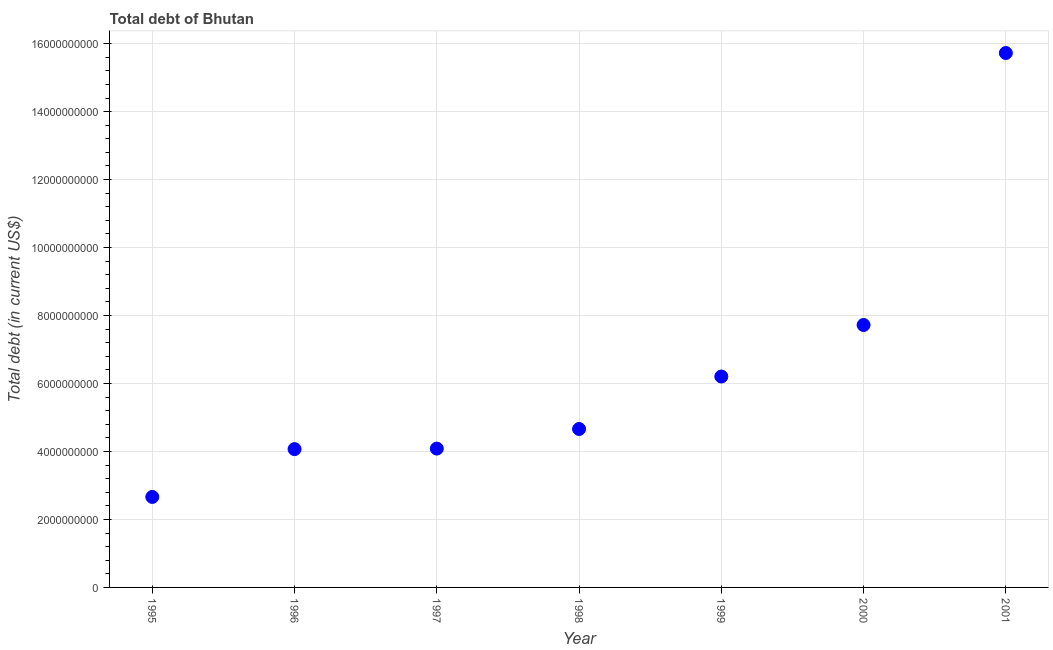What is the total debt in 2000?
Provide a short and direct response. 7.72e+09. Across all years, what is the maximum total debt?
Provide a succinct answer. 1.57e+1. Across all years, what is the minimum total debt?
Provide a short and direct response. 2.66e+09. In which year was the total debt maximum?
Offer a very short reply. 2001. In which year was the total debt minimum?
Give a very brief answer. 1995. What is the sum of the total debt?
Provide a short and direct response. 4.51e+1. What is the difference between the total debt in 1995 and 1998?
Your answer should be very brief. -2.00e+09. What is the average total debt per year?
Keep it short and to the point. 6.45e+09. What is the median total debt?
Make the answer very short. 4.66e+09. What is the ratio of the total debt in 1999 to that in 2000?
Your response must be concise. 0.8. Is the difference between the total debt in 1999 and 2001 greater than the difference between any two years?
Provide a short and direct response. No. What is the difference between the highest and the second highest total debt?
Keep it short and to the point. 8.00e+09. What is the difference between the highest and the lowest total debt?
Make the answer very short. 1.31e+1. In how many years, is the total debt greater than the average total debt taken over all years?
Your answer should be compact. 2. Does the total debt monotonically increase over the years?
Give a very brief answer. Yes. How many dotlines are there?
Provide a short and direct response. 1. How many years are there in the graph?
Your answer should be compact. 7. What is the difference between two consecutive major ticks on the Y-axis?
Give a very brief answer. 2.00e+09. Does the graph contain grids?
Offer a very short reply. Yes. What is the title of the graph?
Make the answer very short. Total debt of Bhutan. What is the label or title of the Y-axis?
Keep it short and to the point. Total debt (in current US$). What is the Total debt (in current US$) in 1995?
Offer a very short reply. 2.66e+09. What is the Total debt (in current US$) in 1996?
Make the answer very short. 4.07e+09. What is the Total debt (in current US$) in 1997?
Your answer should be very brief. 4.08e+09. What is the Total debt (in current US$) in 1998?
Your answer should be compact. 4.66e+09. What is the Total debt (in current US$) in 1999?
Provide a short and direct response. 6.21e+09. What is the Total debt (in current US$) in 2000?
Give a very brief answer. 7.72e+09. What is the Total debt (in current US$) in 2001?
Offer a very short reply. 1.57e+1. What is the difference between the Total debt (in current US$) in 1995 and 1996?
Your answer should be compact. -1.41e+09. What is the difference between the Total debt (in current US$) in 1995 and 1997?
Your answer should be very brief. -1.42e+09. What is the difference between the Total debt (in current US$) in 1995 and 1998?
Offer a terse response. -2.00e+09. What is the difference between the Total debt (in current US$) in 1995 and 1999?
Offer a very short reply. -3.54e+09. What is the difference between the Total debt (in current US$) in 1995 and 2000?
Give a very brief answer. -5.06e+09. What is the difference between the Total debt (in current US$) in 1995 and 2001?
Ensure brevity in your answer.  -1.31e+1. What is the difference between the Total debt (in current US$) in 1996 and 1997?
Provide a short and direct response. -1.54e+07. What is the difference between the Total debt (in current US$) in 1996 and 1998?
Keep it short and to the point. -5.92e+08. What is the difference between the Total debt (in current US$) in 1996 and 1999?
Give a very brief answer. -2.14e+09. What is the difference between the Total debt (in current US$) in 1996 and 2000?
Offer a very short reply. -3.65e+09. What is the difference between the Total debt (in current US$) in 1996 and 2001?
Provide a short and direct response. -1.17e+1. What is the difference between the Total debt (in current US$) in 1997 and 1998?
Keep it short and to the point. -5.76e+08. What is the difference between the Total debt (in current US$) in 1997 and 1999?
Offer a very short reply. -2.12e+09. What is the difference between the Total debt (in current US$) in 1997 and 2000?
Give a very brief answer. -3.64e+09. What is the difference between the Total debt (in current US$) in 1997 and 2001?
Your response must be concise. -1.16e+1. What is the difference between the Total debt (in current US$) in 1998 and 1999?
Your answer should be compact. -1.54e+09. What is the difference between the Total debt (in current US$) in 1998 and 2000?
Offer a terse response. -3.06e+09. What is the difference between the Total debt (in current US$) in 1998 and 2001?
Make the answer very short. -1.11e+1. What is the difference between the Total debt (in current US$) in 1999 and 2000?
Your answer should be compact. -1.52e+09. What is the difference between the Total debt (in current US$) in 1999 and 2001?
Your response must be concise. -9.52e+09. What is the difference between the Total debt (in current US$) in 2000 and 2001?
Your answer should be compact. -8.00e+09. What is the ratio of the Total debt (in current US$) in 1995 to that in 1996?
Offer a very short reply. 0.65. What is the ratio of the Total debt (in current US$) in 1995 to that in 1997?
Make the answer very short. 0.65. What is the ratio of the Total debt (in current US$) in 1995 to that in 1998?
Give a very brief answer. 0.57. What is the ratio of the Total debt (in current US$) in 1995 to that in 1999?
Your answer should be compact. 0.43. What is the ratio of the Total debt (in current US$) in 1995 to that in 2000?
Give a very brief answer. 0.34. What is the ratio of the Total debt (in current US$) in 1995 to that in 2001?
Provide a succinct answer. 0.17. What is the ratio of the Total debt (in current US$) in 1996 to that in 1997?
Give a very brief answer. 1. What is the ratio of the Total debt (in current US$) in 1996 to that in 1998?
Keep it short and to the point. 0.87. What is the ratio of the Total debt (in current US$) in 1996 to that in 1999?
Provide a short and direct response. 0.66. What is the ratio of the Total debt (in current US$) in 1996 to that in 2000?
Provide a succinct answer. 0.53. What is the ratio of the Total debt (in current US$) in 1996 to that in 2001?
Your answer should be very brief. 0.26. What is the ratio of the Total debt (in current US$) in 1997 to that in 1998?
Provide a short and direct response. 0.88. What is the ratio of the Total debt (in current US$) in 1997 to that in 1999?
Your answer should be compact. 0.66. What is the ratio of the Total debt (in current US$) in 1997 to that in 2000?
Offer a very short reply. 0.53. What is the ratio of the Total debt (in current US$) in 1997 to that in 2001?
Keep it short and to the point. 0.26. What is the ratio of the Total debt (in current US$) in 1998 to that in 1999?
Offer a very short reply. 0.75. What is the ratio of the Total debt (in current US$) in 1998 to that in 2000?
Offer a terse response. 0.6. What is the ratio of the Total debt (in current US$) in 1998 to that in 2001?
Offer a terse response. 0.3. What is the ratio of the Total debt (in current US$) in 1999 to that in 2000?
Your answer should be very brief. 0.8. What is the ratio of the Total debt (in current US$) in 1999 to that in 2001?
Ensure brevity in your answer.  0.4. What is the ratio of the Total debt (in current US$) in 2000 to that in 2001?
Keep it short and to the point. 0.49. 